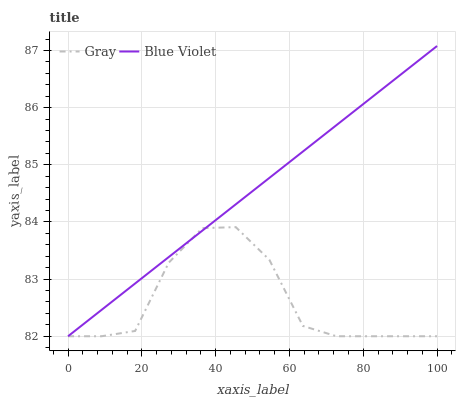Does Gray have the minimum area under the curve?
Answer yes or no. Yes. Does Blue Violet have the maximum area under the curve?
Answer yes or no. Yes. Does Blue Violet have the minimum area under the curve?
Answer yes or no. No. Is Blue Violet the smoothest?
Answer yes or no. Yes. Is Gray the roughest?
Answer yes or no. Yes. Is Blue Violet the roughest?
Answer yes or no. No. Does Gray have the lowest value?
Answer yes or no. Yes. Does Blue Violet have the highest value?
Answer yes or no. Yes. Does Blue Violet intersect Gray?
Answer yes or no. Yes. Is Blue Violet less than Gray?
Answer yes or no. No. Is Blue Violet greater than Gray?
Answer yes or no. No. 